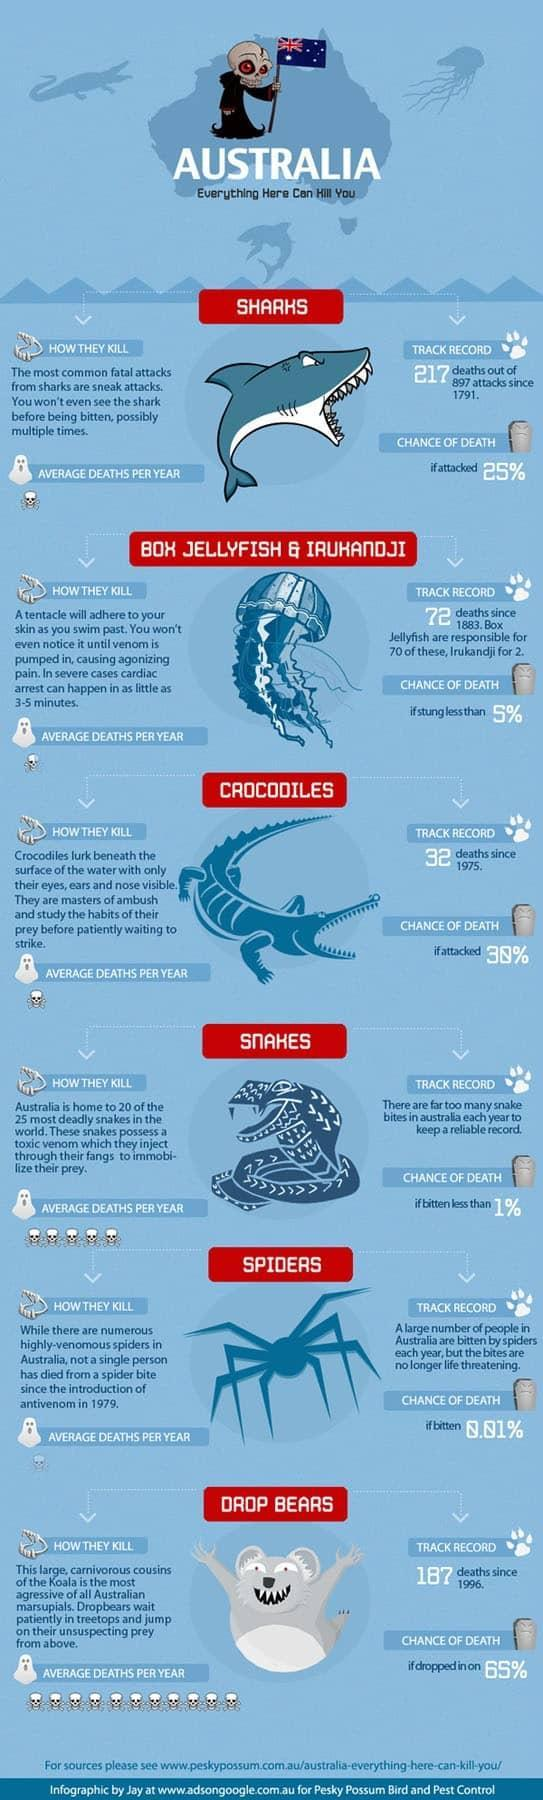What is the average chance of death if bitten by a snake in Australia?
Answer the question with a short phrase. less than 1% What is the chance of survival after the shark attack? 75% What is the average deaths per year caused by fatal shark attacks in Australia? 1 What is the chance of survival if dropped in on by drop bear? 35% What is the number of deaths caused by shark attacks since 1791 in Australia? 217 deaths What is the average deaths per year caused by crocodile attacks in Australia? 1 What is the number of deaths caused by drop bears since 1996 in Australia? 187 What is the average deaths per year caused by snake bites in Australia? 5 What is the number of deaths caused by crocodile attacks since 1975 in Australia? 32 deaths What is the chance of survival after the crocodile attack? 70% 